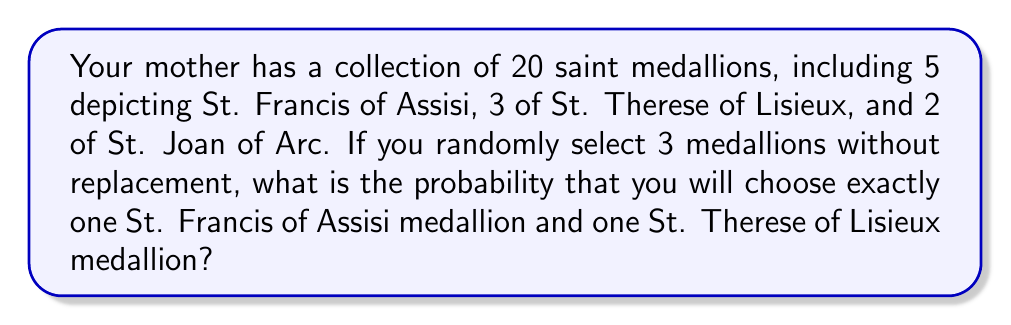Give your solution to this math problem. Let's approach this step-by-step:

1) First, we need to calculate the total number of ways to select 3 medallions out of 20. This is given by the combination formula:

   $$\binom{20}{3} = \frac{20!}{3!(20-3)!} = \frac{20!}{3!17!} = 1140$$

2) Now, we need to calculate the number of ways to select:
   - 1 St. Francis medallion (out of 5)
   - 1 St. Therese medallion (out of 3)
   - 1 medallion from the remaining saints (20 - 5 - 3 = 12)

3) This can be calculated as:

   $$\binom{5}{1} \times \binom{3}{1} \times \binom{12}{1} = 5 \times 3 \times 12 = 180$$

4) The probability is then the number of favorable outcomes divided by the total number of possible outcomes:

   $$P(\text{1 St. Francis, 1 St. Therese, 1 other}) = \frac{180}{1140} = \frac{3}{19} \approx 0.1579$$
Answer: $\frac{3}{19}$ or approximately 0.1579 or 15.79% 